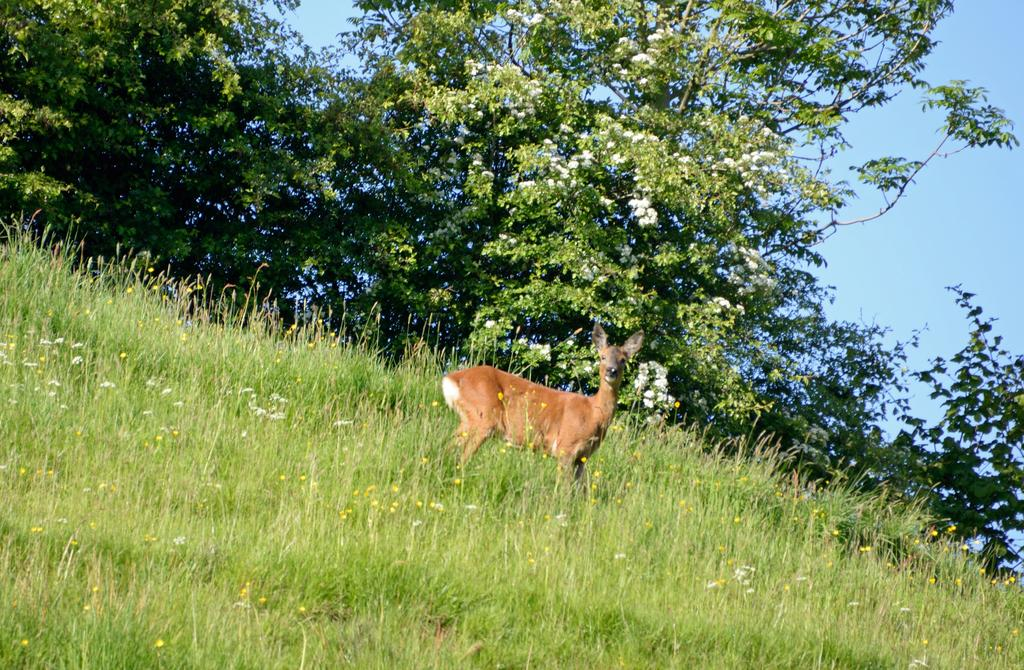What type of vegetation is at the bottom of the image? There is grass at the bottom of the image. What animal can be seen standing in the grass? A deer is standing in the grass. What can be seen in the distance in the image? There are many trees in the background of the image. What is visible above the trees in the image? The sky is visible in the background of the image. Where is the sack of apples that the deer's friend brought in the image? There is no sack of apples or friend mentioned in the image; it only features a deer standing in the grass. 